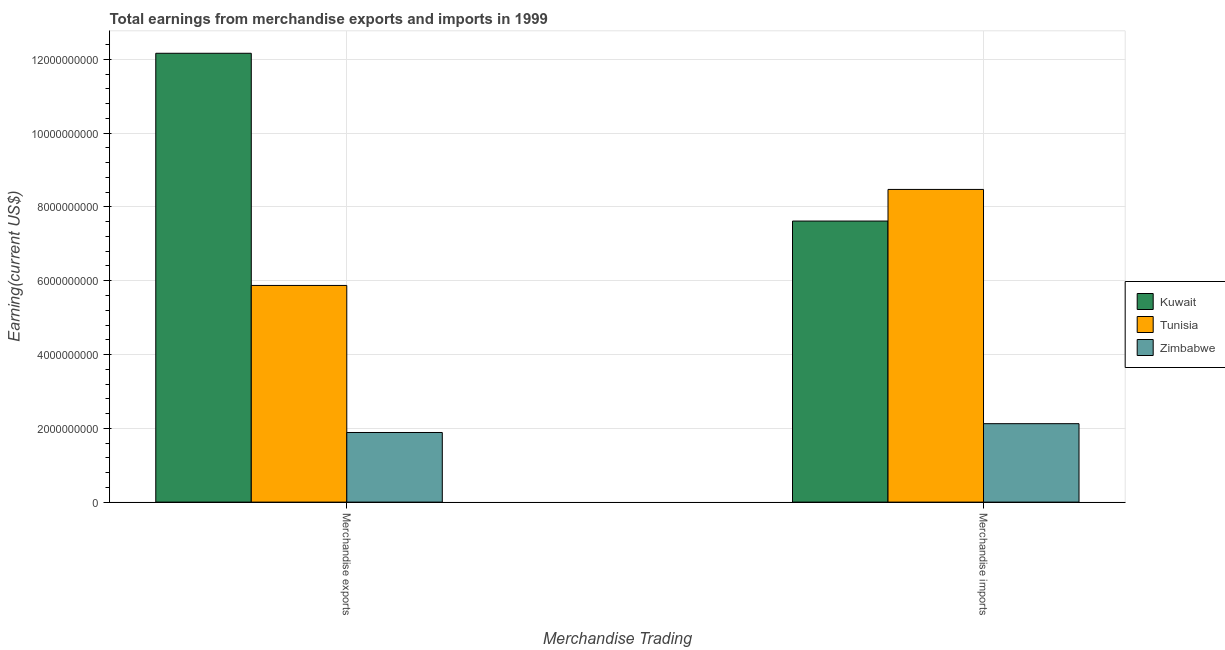How many different coloured bars are there?
Your answer should be very brief. 3. Are the number of bars on each tick of the X-axis equal?
Your response must be concise. Yes. How many bars are there on the 1st tick from the left?
Make the answer very short. 3. What is the earnings from merchandise imports in Kuwait?
Give a very brief answer. 7.62e+09. Across all countries, what is the maximum earnings from merchandise exports?
Offer a terse response. 1.22e+1. Across all countries, what is the minimum earnings from merchandise exports?
Give a very brief answer. 1.89e+09. In which country was the earnings from merchandise imports maximum?
Ensure brevity in your answer.  Tunisia. In which country was the earnings from merchandise exports minimum?
Ensure brevity in your answer.  Zimbabwe. What is the total earnings from merchandise imports in the graph?
Ensure brevity in your answer.  1.82e+1. What is the difference between the earnings from merchandise exports in Kuwait and that in Tunisia?
Offer a very short reply. 6.29e+09. What is the difference between the earnings from merchandise imports in Zimbabwe and the earnings from merchandise exports in Tunisia?
Your answer should be very brief. -3.75e+09. What is the average earnings from merchandise imports per country?
Ensure brevity in your answer.  6.07e+09. What is the difference between the earnings from merchandise exports and earnings from merchandise imports in Kuwait?
Keep it short and to the point. 4.55e+09. What is the ratio of the earnings from merchandise exports in Zimbabwe to that in Kuwait?
Offer a terse response. 0.16. In how many countries, is the earnings from merchandise exports greater than the average earnings from merchandise exports taken over all countries?
Your answer should be compact. 1. What does the 3rd bar from the left in Merchandise imports represents?
Provide a short and direct response. Zimbabwe. What does the 1st bar from the right in Merchandise exports represents?
Provide a succinct answer. Zimbabwe. Are all the bars in the graph horizontal?
Provide a succinct answer. No. What is the difference between two consecutive major ticks on the Y-axis?
Keep it short and to the point. 2.00e+09. Does the graph contain grids?
Offer a very short reply. Yes. How many legend labels are there?
Your answer should be very brief. 3. How are the legend labels stacked?
Give a very brief answer. Vertical. What is the title of the graph?
Your answer should be very brief. Total earnings from merchandise exports and imports in 1999. What is the label or title of the X-axis?
Make the answer very short. Merchandise Trading. What is the label or title of the Y-axis?
Ensure brevity in your answer.  Earning(current US$). What is the Earning(current US$) in Kuwait in Merchandise exports?
Offer a terse response. 1.22e+1. What is the Earning(current US$) in Tunisia in Merchandise exports?
Offer a terse response. 5.87e+09. What is the Earning(current US$) in Zimbabwe in Merchandise exports?
Keep it short and to the point. 1.89e+09. What is the Earning(current US$) in Kuwait in Merchandise imports?
Offer a very short reply. 7.62e+09. What is the Earning(current US$) of Tunisia in Merchandise imports?
Give a very brief answer. 8.47e+09. What is the Earning(current US$) in Zimbabwe in Merchandise imports?
Offer a terse response. 2.13e+09. Across all Merchandise Trading, what is the maximum Earning(current US$) in Kuwait?
Give a very brief answer. 1.22e+1. Across all Merchandise Trading, what is the maximum Earning(current US$) in Tunisia?
Your answer should be compact. 8.47e+09. Across all Merchandise Trading, what is the maximum Earning(current US$) in Zimbabwe?
Offer a terse response. 2.13e+09. Across all Merchandise Trading, what is the minimum Earning(current US$) of Kuwait?
Your answer should be compact. 7.62e+09. Across all Merchandise Trading, what is the minimum Earning(current US$) of Tunisia?
Ensure brevity in your answer.  5.87e+09. Across all Merchandise Trading, what is the minimum Earning(current US$) in Zimbabwe?
Offer a terse response. 1.89e+09. What is the total Earning(current US$) in Kuwait in the graph?
Ensure brevity in your answer.  1.98e+1. What is the total Earning(current US$) in Tunisia in the graph?
Keep it short and to the point. 1.43e+1. What is the total Earning(current US$) in Zimbabwe in the graph?
Your answer should be very brief. 4.01e+09. What is the difference between the Earning(current US$) of Kuwait in Merchandise exports and that in Merchandise imports?
Provide a succinct answer. 4.55e+09. What is the difference between the Earning(current US$) in Tunisia in Merchandise exports and that in Merchandise imports?
Your response must be concise. -2.60e+09. What is the difference between the Earning(current US$) in Zimbabwe in Merchandise exports and that in Merchandise imports?
Offer a terse response. -2.39e+08. What is the difference between the Earning(current US$) in Kuwait in Merchandise exports and the Earning(current US$) in Tunisia in Merchandise imports?
Provide a succinct answer. 3.69e+09. What is the difference between the Earning(current US$) of Kuwait in Merchandise exports and the Earning(current US$) of Zimbabwe in Merchandise imports?
Provide a short and direct response. 1.00e+1. What is the difference between the Earning(current US$) in Tunisia in Merchandise exports and the Earning(current US$) in Zimbabwe in Merchandise imports?
Give a very brief answer. 3.75e+09. What is the average Earning(current US$) of Kuwait per Merchandise Trading?
Your response must be concise. 9.89e+09. What is the average Earning(current US$) of Tunisia per Merchandise Trading?
Your answer should be very brief. 7.17e+09. What is the average Earning(current US$) in Zimbabwe per Merchandise Trading?
Ensure brevity in your answer.  2.01e+09. What is the difference between the Earning(current US$) of Kuwait and Earning(current US$) of Tunisia in Merchandise exports?
Your answer should be very brief. 6.29e+09. What is the difference between the Earning(current US$) of Kuwait and Earning(current US$) of Zimbabwe in Merchandise exports?
Your response must be concise. 1.03e+1. What is the difference between the Earning(current US$) in Tunisia and Earning(current US$) in Zimbabwe in Merchandise exports?
Keep it short and to the point. 3.98e+09. What is the difference between the Earning(current US$) of Kuwait and Earning(current US$) of Tunisia in Merchandise imports?
Keep it short and to the point. -8.57e+08. What is the difference between the Earning(current US$) in Kuwait and Earning(current US$) in Zimbabwe in Merchandise imports?
Your answer should be very brief. 5.49e+09. What is the difference between the Earning(current US$) of Tunisia and Earning(current US$) of Zimbabwe in Merchandise imports?
Your answer should be compact. 6.35e+09. What is the ratio of the Earning(current US$) in Kuwait in Merchandise exports to that in Merchandise imports?
Keep it short and to the point. 1.6. What is the ratio of the Earning(current US$) of Tunisia in Merchandise exports to that in Merchandise imports?
Offer a terse response. 0.69. What is the ratio of the Earning(current US$) in Zimbabwe in Merchandise exports to that in Merchandise imports?
Ensure brevity in your answer.  0.89. What is the difference between the highest and the second highest Earning(current US$) in Kuwait?
Offer a very short reply. 4.55e+09. What is the difference between the highest and the second highest Earning(current US$) in Tunisia?
Give a very brief answer. 2.60e+09. What is the difference between the highest and the second highest Earning(current US$) of Zimbabwe?
Ensure brevity in your answer.  2.39e+08. What is the difference between the highest and the lowest Earning(current US$) of Kuwait?
Make the answer very short. 4.55e+09. What is the difference between the highest and the lowest Earning(current US$) of Tunisia?
Your answer should be very brief. 2.60e+09. What is the difference between the highest and the lowest Earning(current US$) of Zimbabwe?
Keep it short and to the point. 2.39e+08. 